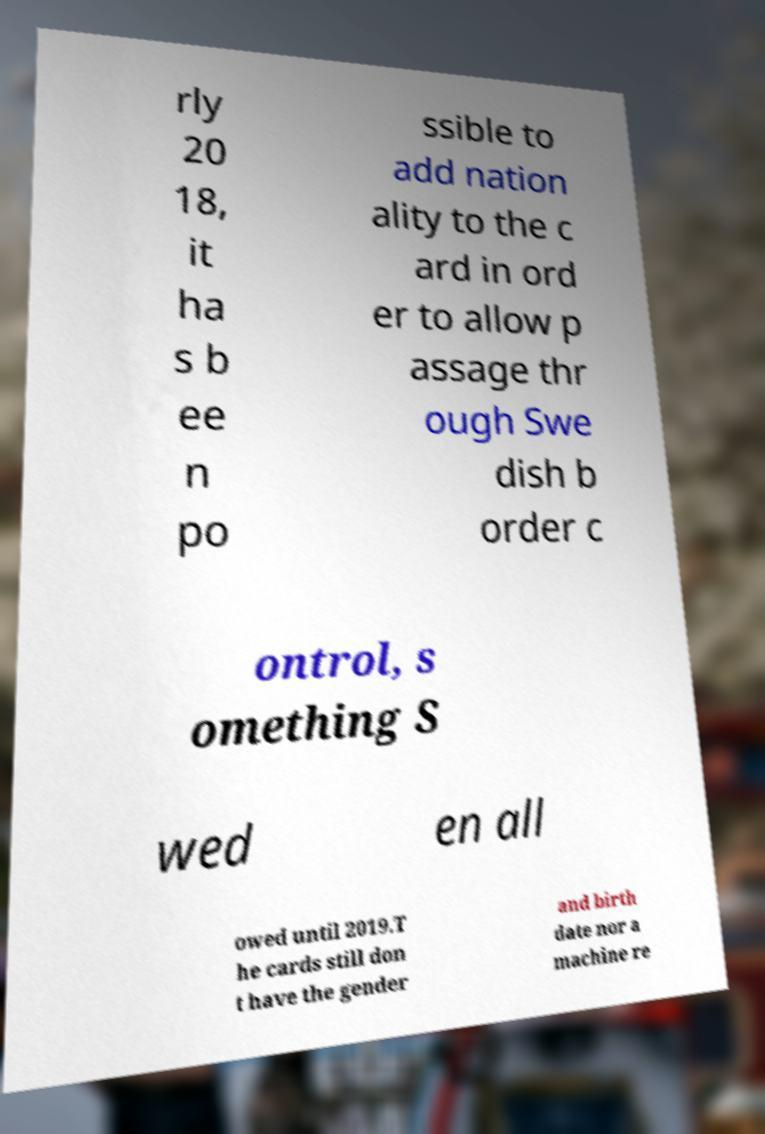Could you extract and type out the text from this image? rly 20 18, it ha s b ee n po ssible to add nation ality to the c ard in ord er to allow p assage thr ough Swe dish b order c ontrol, s omething S wed en all owed until 2019.T he cards still don t have the gender and birth date nor a machine re 